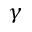<formula> <loc_0><loc_0><loc_500><loc_500>\gamma</formula> 